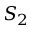Convert formula to latex. <formula><loc_0><loc_0><loc_500><loc_500>S _ { 2 }</formula> 